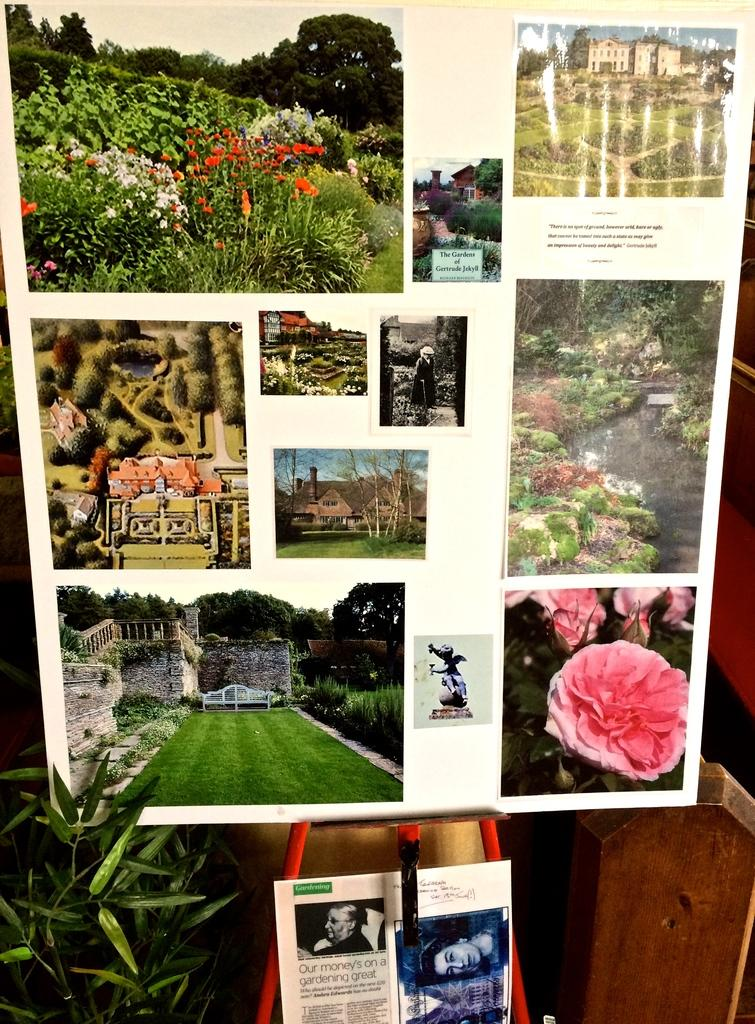What is the main object in the image? The main object in the image is a white color board with pictures posted on it. What is located at the bottom of the image? There is a plant and a picture at the bottom of the image. Can you describe the wooden object in the image? There is a wooden thing present in the right bottom of the image. What type of skirt is the father wearing in the image? There is no father or skirt present in the image. 